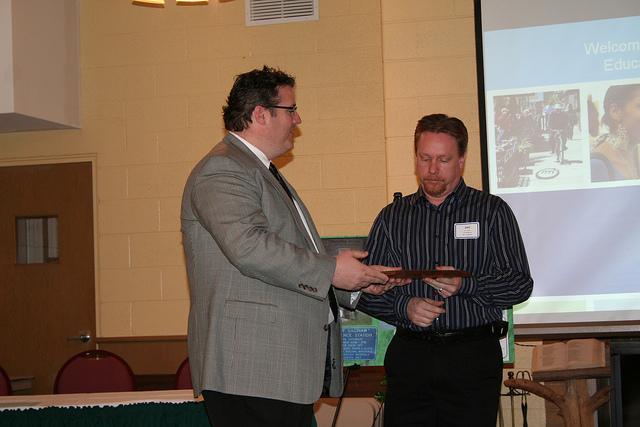Where is the word 'welcome'?
Answer briefly. On screen. What are these people looking at?
Answer briefly. Plaque. How many people?
Be succinct. 2. Is the man wearing a tie?
Short answer required. Yes. Is this a business presentation?
Keep it brief. Yes. 